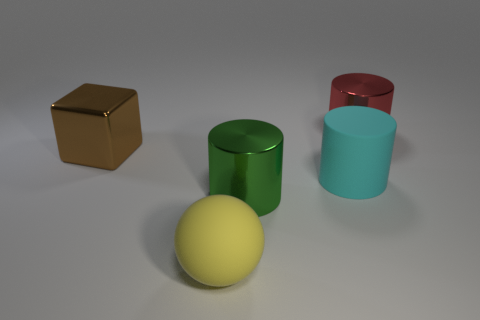Subtract all metallic cylinders. How many cylinders are left? 1 Add 1 big red objects. How many objects exist? 6 Subtract all balls. How many objects are left? 4 Subtract all brown cylinders. Subtract all purple balls. How many cylinders are left? 3 Add 2 cylinders. How many cylinders exist? 5 Subtract 1 green cylinders. How many objects are left? 4 Subtract all green shiny cylinders. Subtract all large blue cylinders. How many objects are left? 4 Add 2 red shiny cylinders. How many red shiny cylinders are left? 3 